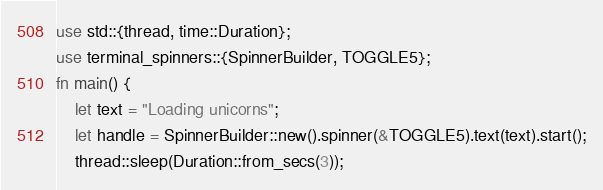<code> <loc_0><loc_0><loc_500><loc_500><_Rust_>use std::{thread, time::Duration};
use terminal_spinners::{SpinnerBuilder, TOGGLE5};
fn main() {
    let text = "Loading unicorns";
    let handle = SpinnerBuilder::new().spinner(&TOGGLE5).text(text).start();
    thread::sleep(Duration::from_secs(3));</code> 